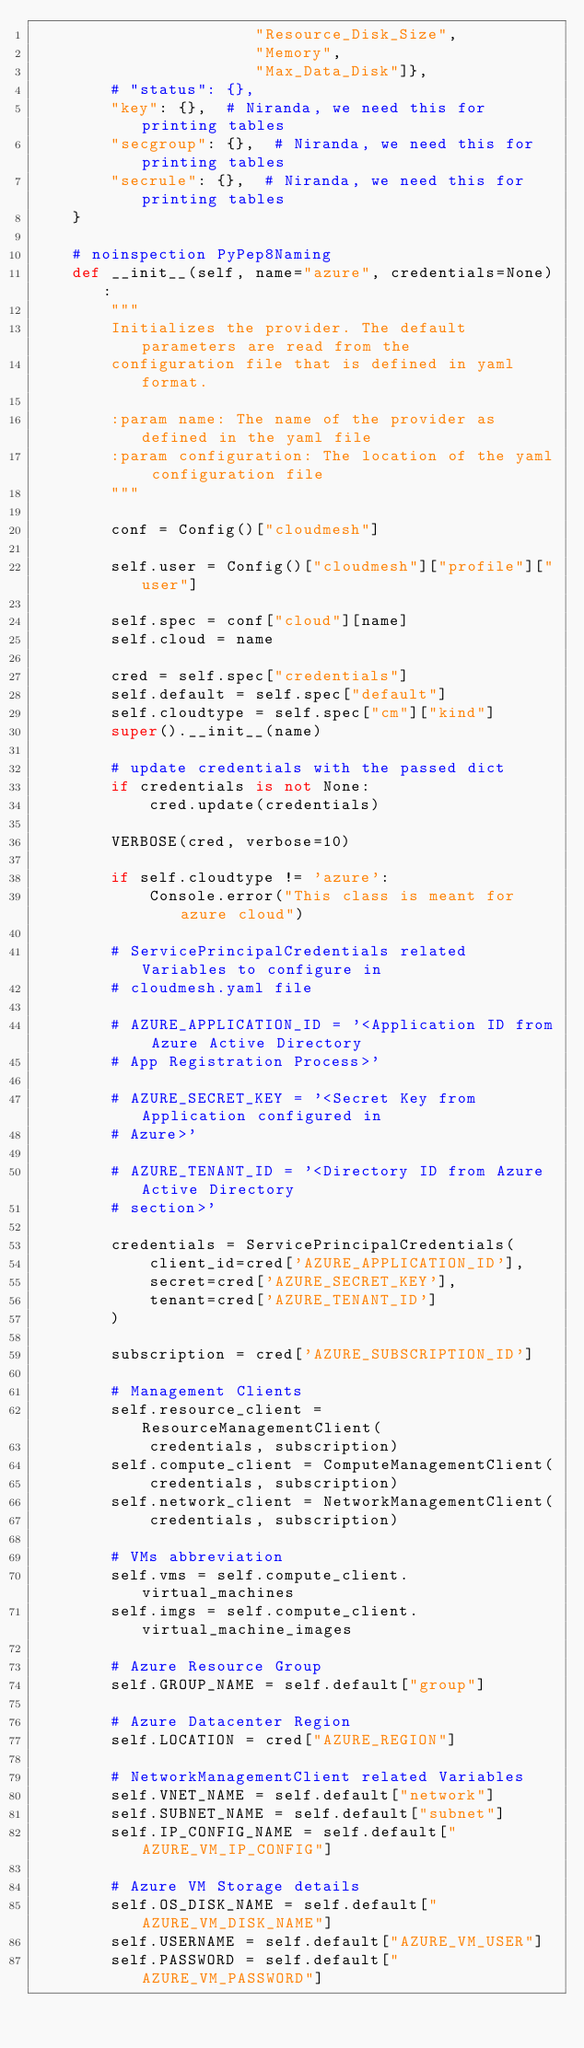Convert code to text. <code><loc_0><loc_0><loc_500><loc_500><_Python_>                       "Resource_Disk_Size",
                       "Memory",
                       "Max_Data_Disk"]},
        # "status": {},
        "key": {},  # Niranda, we need this for printing tables
        "secgroup": {},  # Niranda, we need this for printing tables
        "secrule": {},  # Niranda, we need this for printing tables
    }

    # noinspection PyPep8Naming
    def __init__(self, name="azure", credentials=None):
        """
        Initializes the provider. The default parameters are read from the
        configuration file that is defined in yaml format.

        :param name: The name of the provider as defined in the yaml file
        :param configuration: The location of the yaml configuration file
        """

        conf = Config()["cloudmesh"]

        self.user = Config()["cloudmesh"]["profile"]["user"]

        self.spec = conf["cloud"][name]
        self.cloud = name

        cred = self.spec["credentials"]
        self.default = self.spec["default"]
        self.cloudtype = self.spec["cm"]["kind"]
        super().__init__(name)

        # update credentials with the passed dict
        if credentials is not None:
            cred.update(credentials)

        VERBOSE(cred, verbose=10)

        if self.cloudtype != 'azure':
            Console.error("This class is meant for azure cloud")

        # ServicePrincipalCredentials related Variables to configure in
        # cloudmesh.yaml file

        # AZURE_APPLICATION_ID = '<Application ID from Azure Active Directory
        # App Registration Process>'

        # AZURE_SECRET_KEY = '<Secret Key from Application configured in
        # Azure>'

        # AZURE_TENANT_ID = '<Directory ID from Azure Active Directory
        # section>'

        credentials = ServicePrincipalCredentials(
            client_id=cred['AZURE_APPLICATION_ID'],
            secret=cred['AZURE_SECRET_KEY'],
            tenant=cred['AZURE_TENANT_ID']
        )

        subscription = cred['AZURE_SUBSCRIPTION_ID']

        # Management Clients
        self.resource_client = ResourceManagementClient(
            credentials, subscription)
        self.compute_client = ComputeManagementClient(
            credentials, subscription)
        self.network_client = NetworkManagementClient(
            credentials, subscription)

        # VMs abbreviation
        self.vms = self.compute_client.virtual_machines
        self.imgs = self.compute_client.virtual_machine_images

        # Azure Resource Group
        self.GROUP_NAME = self.default["group"]

        # Azure Datacenter Region
        self.LOCATION = cred["AZURE_REGION"]

        # NetworkManagementClient related Variables
        self.VNET_NAME = self.default["network"]
        self.SUBNET_NAME = self.default["subnet"]
        self.IP_CONFIG_NAME = self.default["AZURE_VM_IP_CONFIG"]

        # Azure VM Storage details
        self.OS_DISK_NAME = self.default["AZURE_VM_DISK_NAME"]
        self.USERNAME = self.default["AZURE_VM_USER"]
        self.PASSWORD = self.default["AZURE_VM_PASSWORD"]</code> 